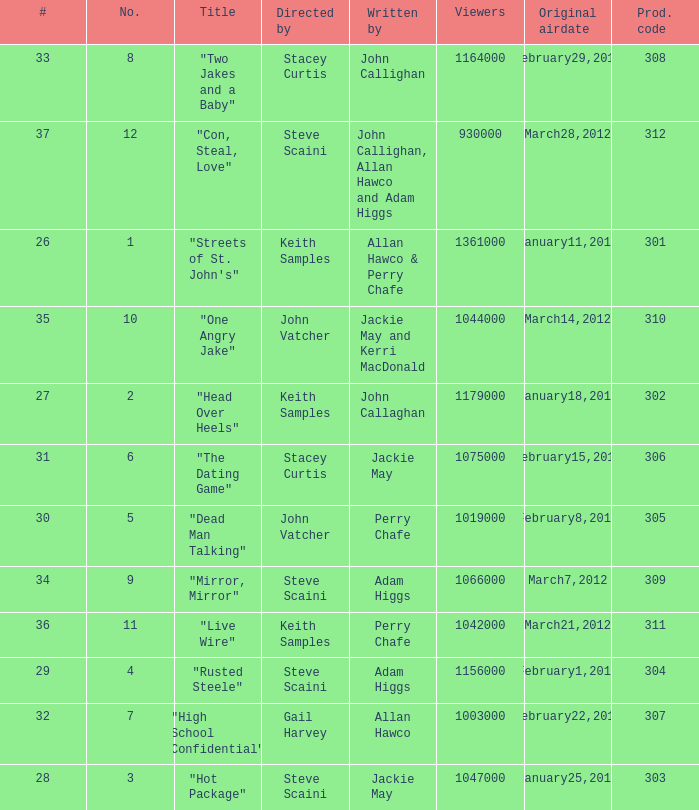What is the total number of films directy and written by john callaghan? 1.0. 